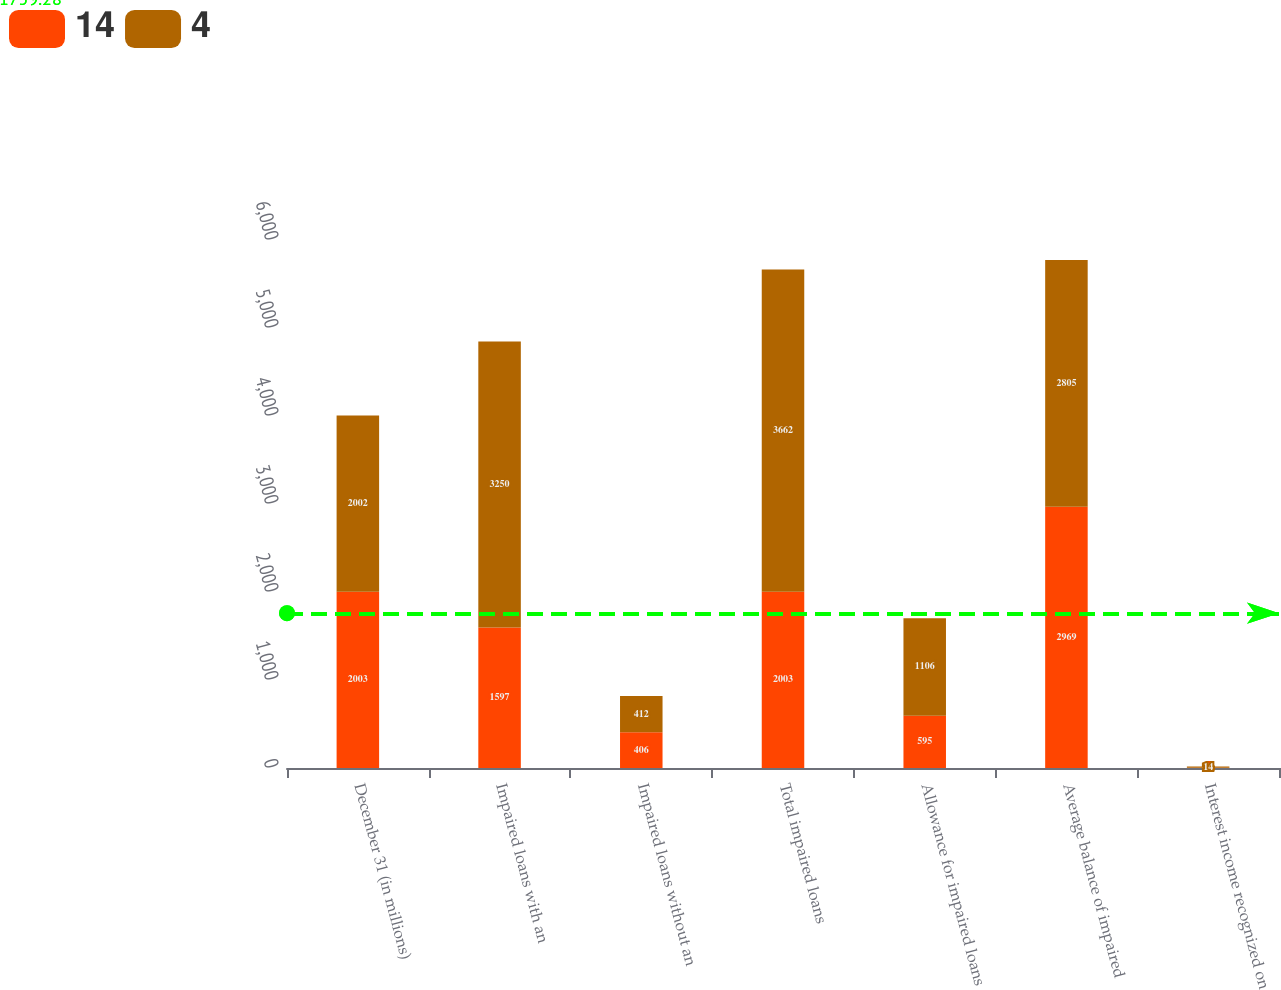<chart> <loc_0><loc_0><loc_500><loc_500><stacked_bar_chart><ecel><fcel>December 31 (in millions)<fcel>Impaired loans with an<fcel>Impaired loans without an<fcel>Total impaired loans<fcel>Allowance for impaired loans<fcel>Average balance of impaired<fcel>Interest income recognized on<nl><fcel>14<fcel>2003<fcel>1597<fcel>406<fcel>2003<fcel>595<fcel>2969<fcel>4<nl><fcel>4<fcel>2002<fcel>3250<fcel>412<fcel>3662<fcel>1106<fcel>2805<fcel>14<nl></chart> 